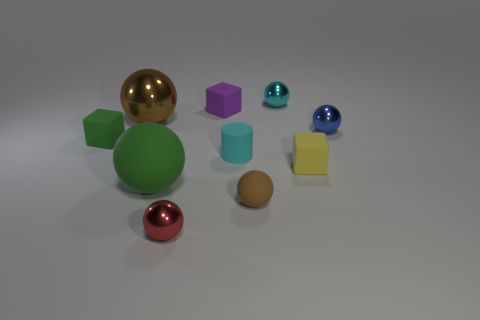There is a object that is the same color as the cylinder; what material is it?
Offer a very short reply. Metal. Are there any other things that have the same shape as the cyan matte thing?
Your answer should be compact. No. What number of metal things are both to the left of the brown rubber thing and on the right side of the small cylinder?
Give a very brief answer. 0. The metallic thing that is to the right of the tiny yellow cube has what shape?
Your response must be concise. Sphere. What number of rubber cylinders are the same size as the green ball?
Your answer should be very brief. 0. There is a large ball that is behind the blue metallic object; does it have the same color as the small rubber ball?
Make the answer very short. Yes. The sphere that is both behind the tiny blue shiny sphere and to the left of the tiny rubber ball is made of what material?
Give a very brief answer. Metal. Is the number of large rubber objects greater than the number of large balls?
Your response must be concise. No. There is a matte cube in front of the object to the left of the brown object that is behind the small cyan cylinder; what color is it?
Keep it short and to the point. Yellow. Is the material of the brown sphere that is to the right of the tiny red shiny thing the same as the cyan cylinder?
Offer a terse response. Yes. 